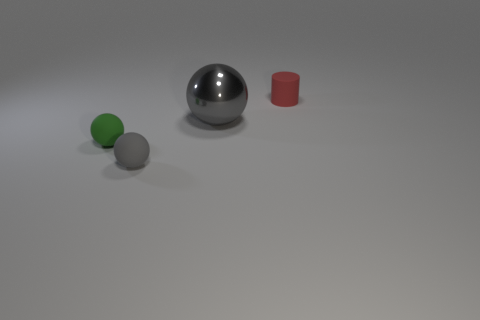What shape is the tiny green object?
Give a very brief answer. Sphere. There is another object that is the same color as the large thing; what size is it?
Offer a terse response. Small. There is a small object that is in front of the small green matte ball; what shape is it?
Your response must be concise. Sphere. There is a rubber thing that is on the right side of the large gray ball; is its color the same as the big metallic thing?
Provide a succinct answer. No. What is the material of the ball that is the same color as the metallic object?
Give a very brief answer. Rubber. There is a sphere in front of the green matte object; is it the same size as the red rubber thing?
Give a very brief answer. Yes. Are there any other large shiny spheres of the same color as the large shiny ball?
Ensure brevity in your answer.  No. Is there a small green rubber object behind the tiny rubber thing behind the large gray metal sphere?
Give a very brief answer. No. Are there any other red cylinders made of the same material as the red cylinder?
Give a very brief answer. No. What material is the tiny thing that is behind the gray ball that is on the right side of the tiny gray rubber object?
Offer a terse response. Rubber. 